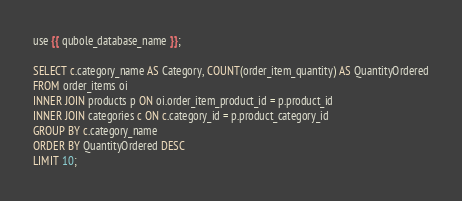Convert code to text. <code><loc_0><loc_0><loc_500><loc_500><_SQL_>use {{ qubole_database_name }};

SELECT c.category_name AS Category, COUNT(order_item_quantity) AS QuantityOrdered
FROM order_items oi
INNER JOIN products p ON oi.order_item_product_id = p.product_id
INNER JOIN categories c ON c.category_id = p.product_category_id
GROUP BY c.category_name
ORDER BY QuantityOrdered DESC
LIMIT 10;</code> 